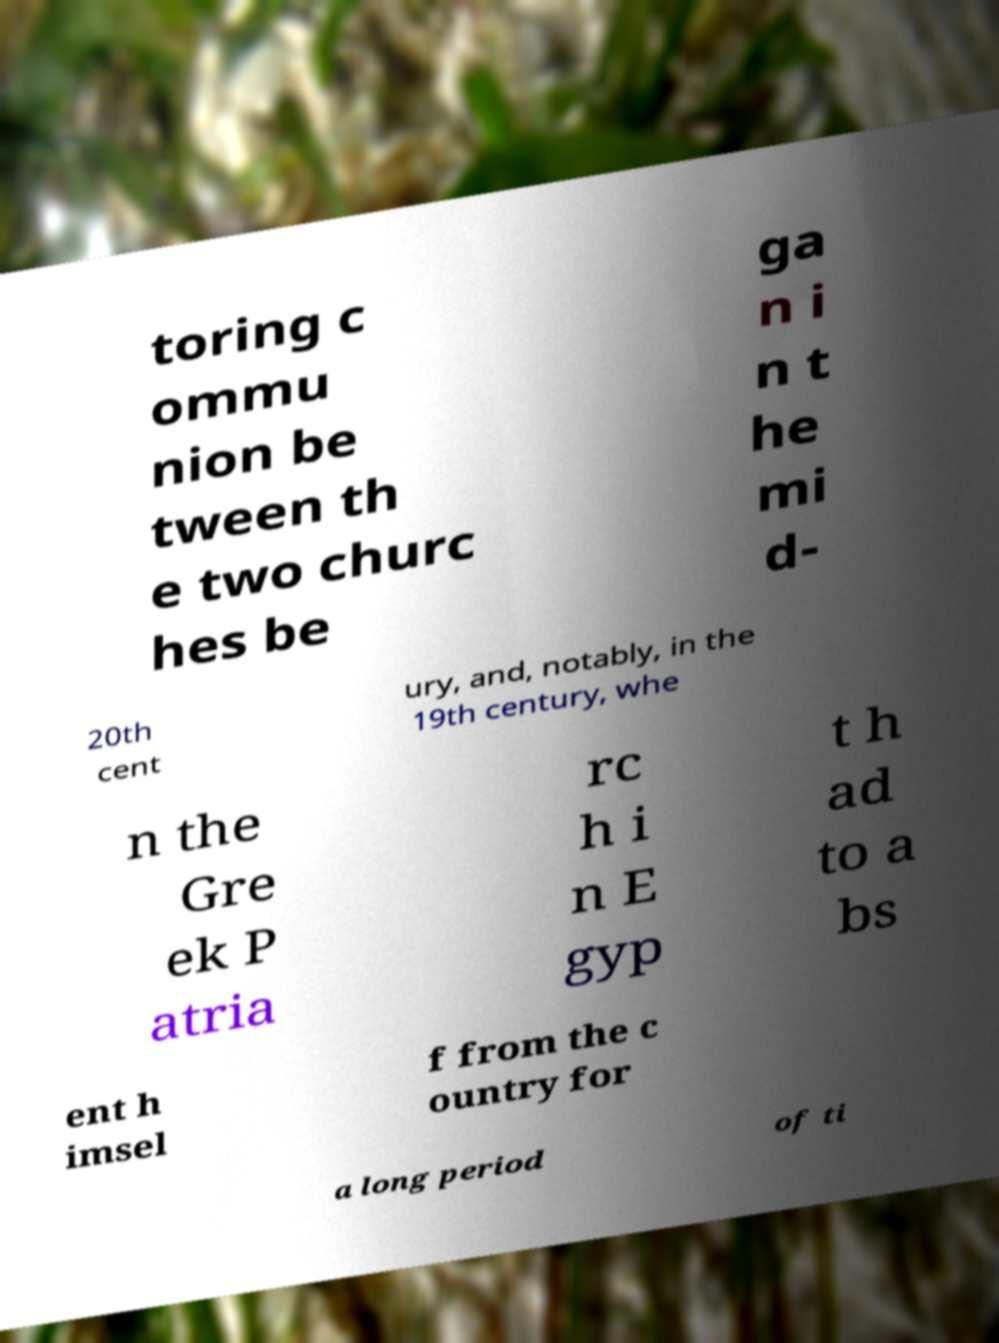Please identify and transcribe the text found in this image. toring c ommu nion be tween th e two churc hes be ga n i n t he mi d- 20th cent ury, and, notably, in the 19th century, whe n the Gre ek P atria rc h i n E gyp t h ad to a bs ent h imsel f from the c ountry for a long period of ti 